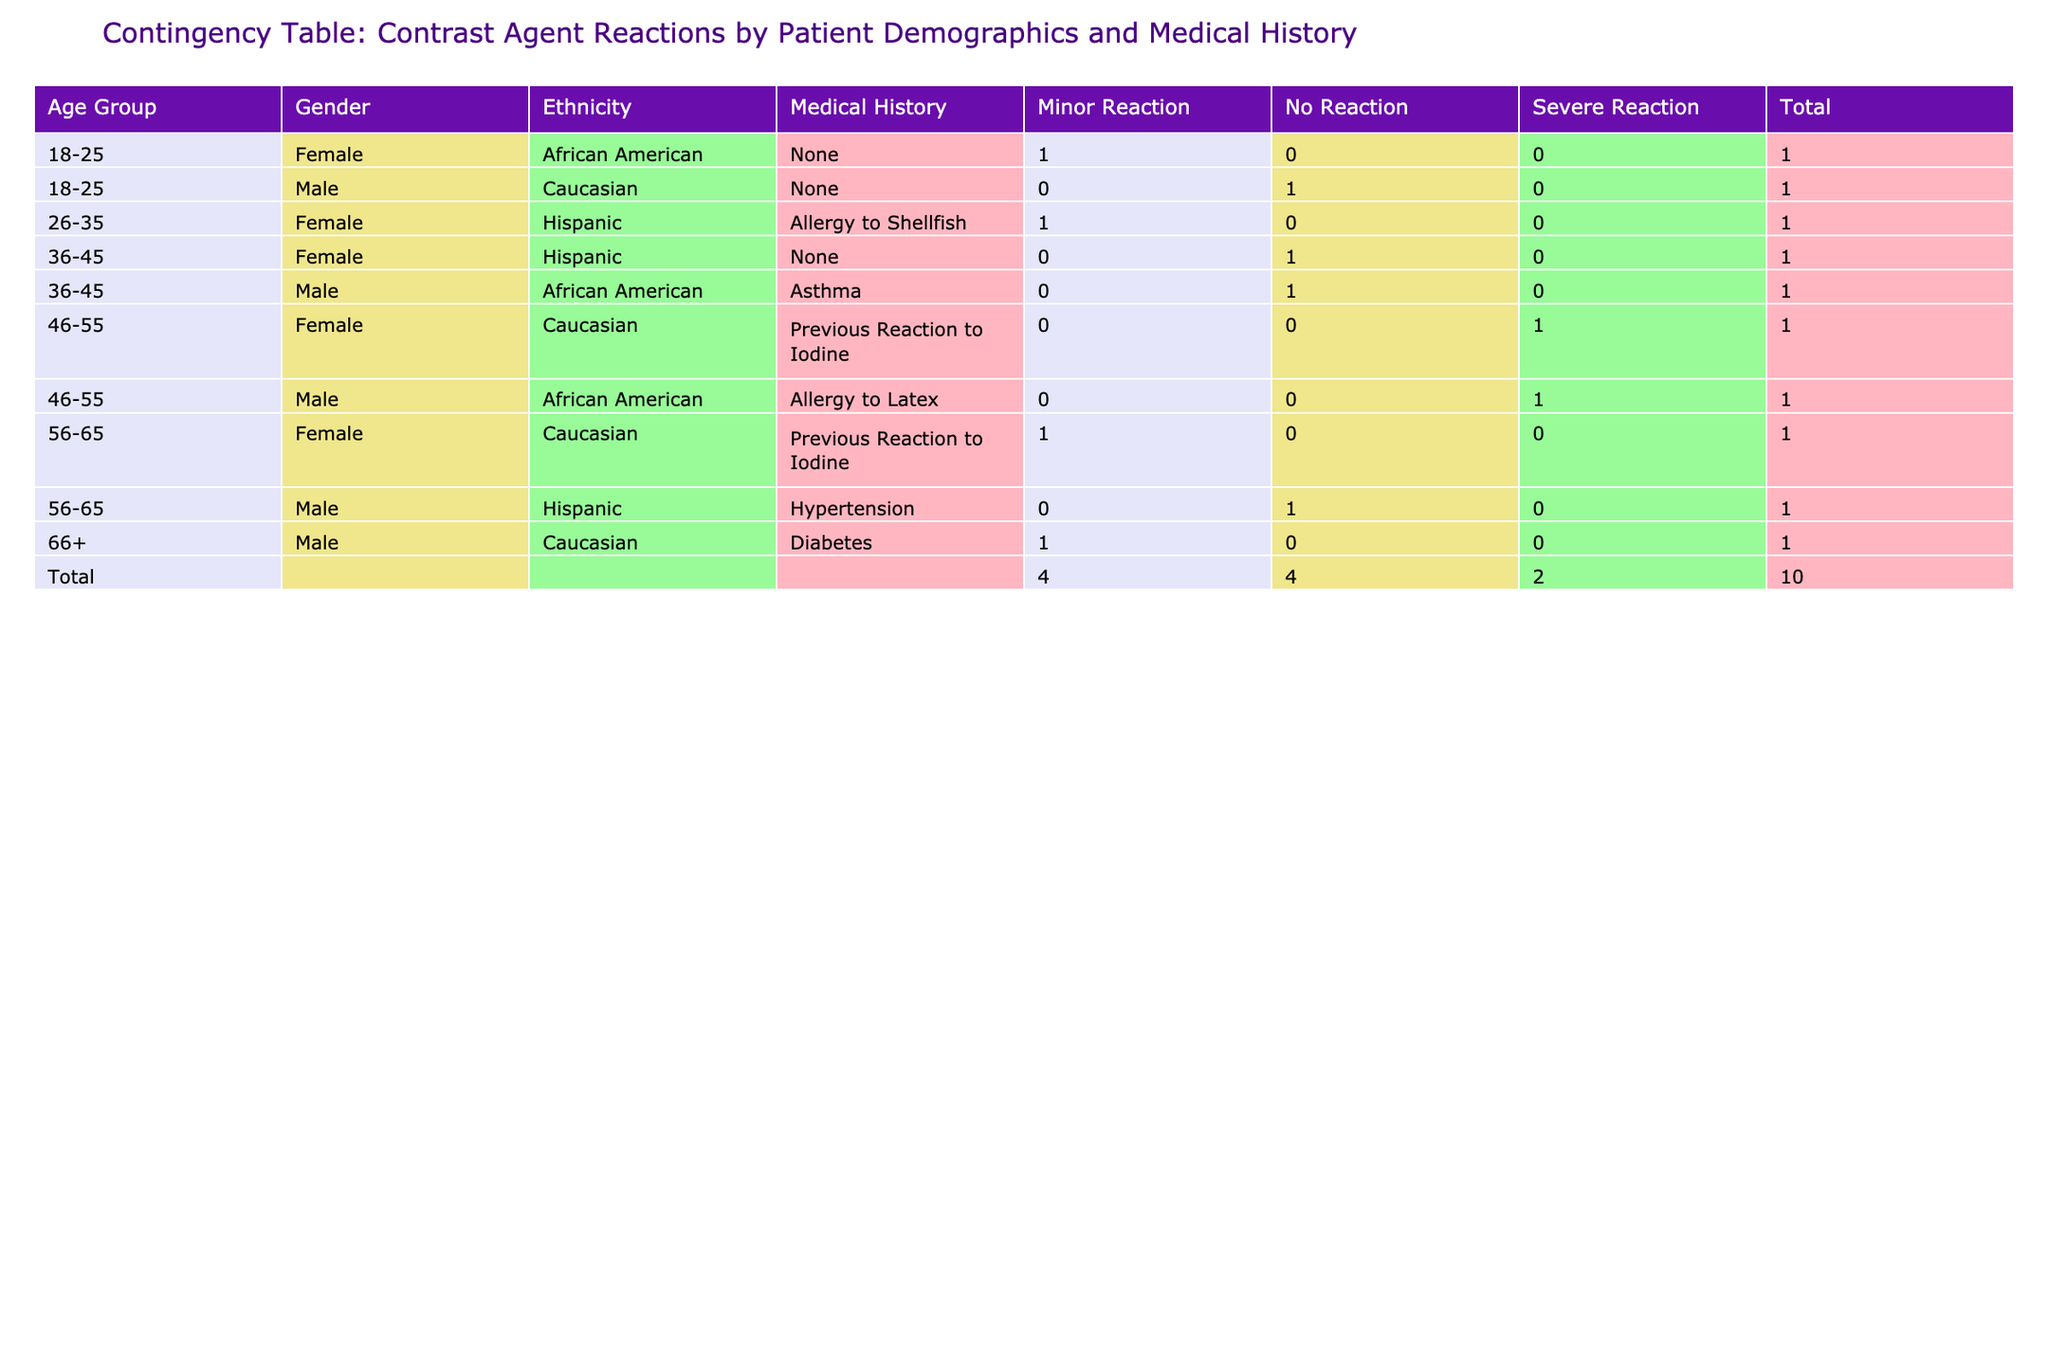What is the total number of patients with a severe reaction? In the table, we can see the patients with a severe reaction are listed under the 'Contrast_Reaction' column. Reviewing the table, there are two instances where the reaction is classified as 'Severe Reaction', specifically for patients 4 and 9. Therefore, adding these up gives us a total of 2 patients.
Answer: 2 What percentage of females experienced no reaction to the contrast agent? We first identify the total number of female patients from the table, which is 5 (patients 2, 6, 4, 10, and 8). Among them, the number who experienced no reaction is 2 (patients 2 and 10). To find the percentage, we calculate (2/5) * 100 = 40%.
Answer: 40% Is there a higher incidence of reactions among patients with a medical history of allergies? Looking at the data, there are 3 patients with a medical history of allergies (patients 2, 4, and 9). Out of these, 2 experienced severe reactions and 1 had a minor reaction. In contrast, among patients without a history of allergies (7 patients), only 2 had any kind of reaction (1 minor and 1 severe). Since 3 out of 3 patients with allergies had reactions compared to 2 out of 7 without, it indicates a higher incidence among allergy patients.
Answer: Yes What is the average age group of patients who experienced a minor reaction? Examining the table, we find that the patients with a minor reaction are 2, 6, 7, and 10. Their corresponding age groups are 26-35, 18-25, 66+, and 56-65. To calculate the average age group numerically, we can assign values: 18-25 = 1, 26-35 = 2, 36-45 = 3, 46-55 = 4, 56-65 = 5, and 66+ = 6. The values for the minor reaction patients are 2, 1, 6, and 5, averaging out to (2 + 1 + 6 + 5) / 4 = 3.5, which corresponds to the age group of 36-45 when mapped back to the age group scale.
Answer: 36-45 Among the male patients, how many had no reaction versus those who had a severe reaction? First, we identify male patients from the table: patients 1, 3, 5, 7, and 9. Out of these, patients 1, 3, 5, and 7 had no reactions (4 patients), while patient 9 had a severe reaction (1 patient). This shows that 4 male patients had no reaction and 1 had a severe reaction.
Answer: No Reaction: 4, Severe Reaction: 1 